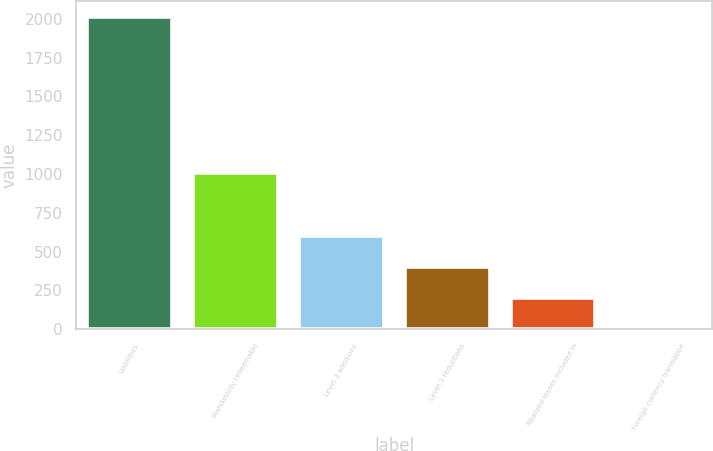<chart> <loc_0><loc_0><loc_500><loc_500><bar_chart><fcel>Liabilities<fcel>Mandatorily redeemable<fcel>Level 3 additions<fcel>Level 3 reductions<fcel>Realized losses included in<fcel>Foreign currency translation<nl><fcel>2011<fcel>1005.55<fcel>603.37<fcel>402.28<fcel>201.19<fcel>0.1<nl></chart> 